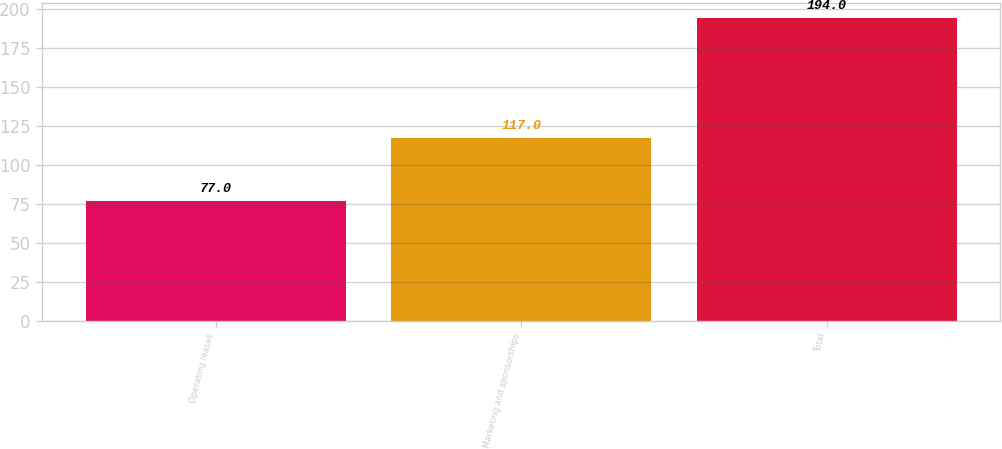Convert chart to OTSL. <chart><loc_0><loc_0><loc_500><loc_500><bar_chart><fcel>Operating leases<fcel>Marketing and sponsorships<fcel>Total<nl><fcel>77<fcel>117<fcel>194<nl></chart> 